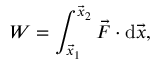Convert formula to latex. <formula><loc_0><loc_0><loc_500><loc_500>W = \int _ { { \vec { x } } _ { 1 } } ^ { { \vec { x } } _ { 2 } } { { \vec { F } } \cdot { d { \vec { x } } } } ,</formula> 